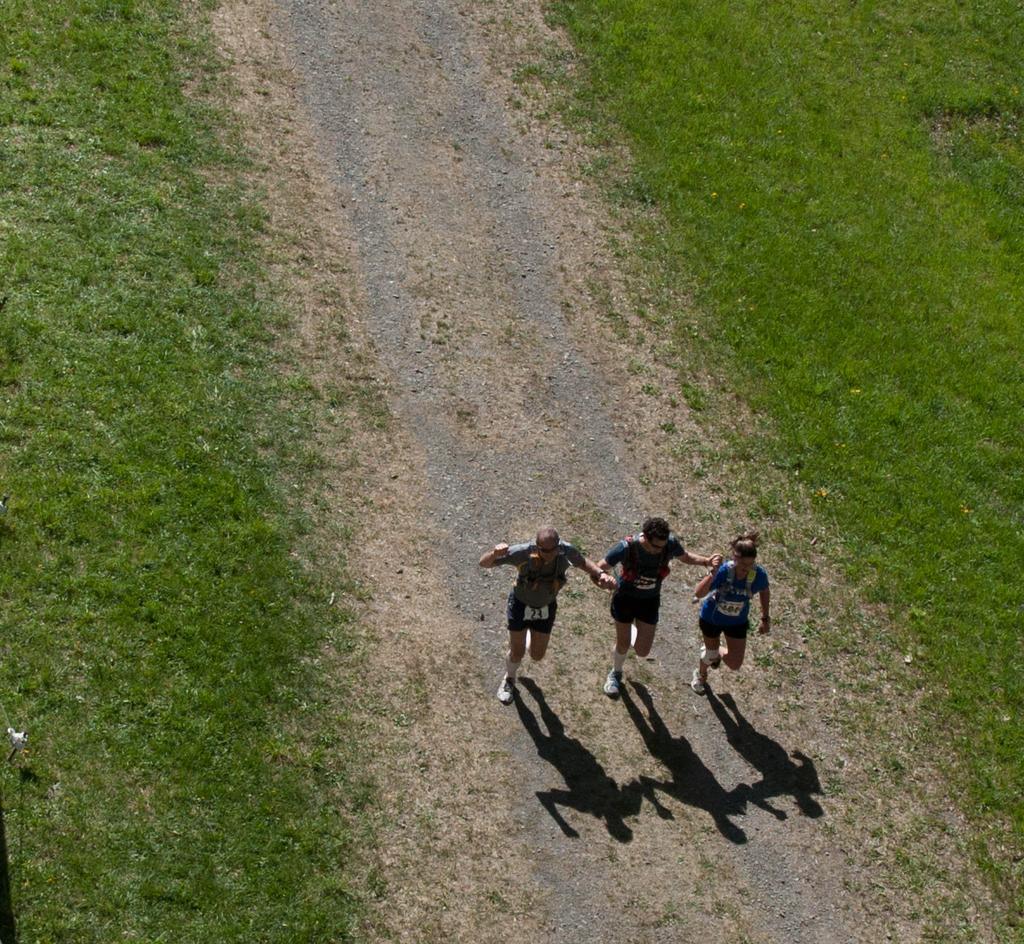How would you summarize this image in a sentence or two? In this picture we can see three persons on the ground and we can see the shadow of them. On the left and ride side of the image we can see grass. 